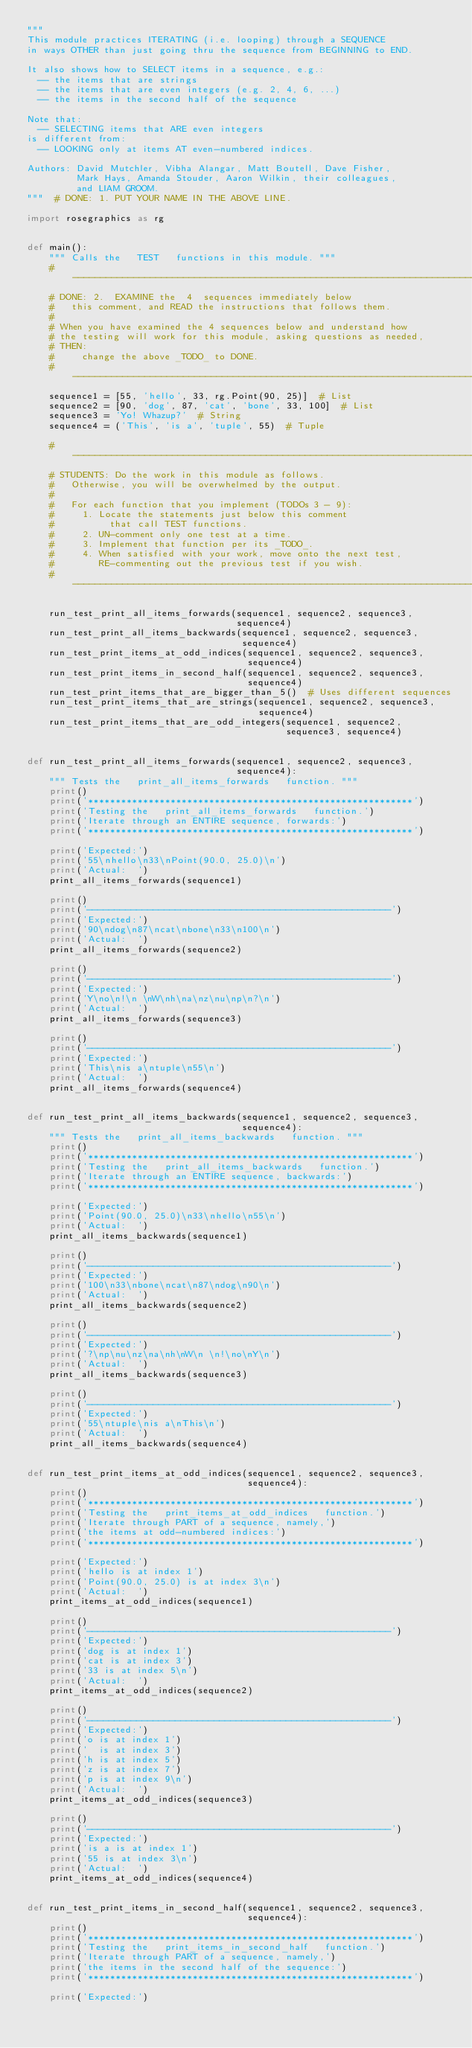<code> <loc_0><loc_0><loc_500><loc_500><_Python_>"""
This module practices ITERATING (i.e. looping) through a SEQUENCE
in ways OTHER than just going thru the sequence from BEGINNING to END.

It also shows how to SELECT items in a sequence, e.g.:
  -- the items that are strings
  -- the items that are even integers (e.g. 2, 4, 6, ...)
  -- the items in the second half of the sequence

Note that:
  -- SELECTING items that ARE even integers
is different from:
  -- LOOKING only at items AT even-numbered indices.

Authors: David Mutchler, Vibha Alangar, Matt Boutell, Dave Fisher,
         Mark Hays, Amanda Stouder, Aaron Wilkin, their colleagues,
         and LIAM GROOM.
"""  # DONE: 1. PUT YOUR NAME IN THE ABOVE LINE.

import rosegraphics as rg


def main():
    """ Calls the   TEST   functions in this module. """
    # -------------------------------------------------------------------------
    # DONE: 2.  EXAMINE the  4  sequences immediately below
    #   this comment, and READ the instructions that follows them.
    #
    # When you have examined the 4 sequences below and understand how
    # the testing will work for this module, asking questions as needed,
    # THEN:
    #     change the above _TODO_ to DONE.
    # -------------------------------------------------------------------------
    sequence1 = [55, 'hello', 33, rg.Point(90, 25)]  # List
    sequence2 = [90, 'dog', 87, 'cat', 'bone', 33, 100]  # List
    sequence3 = 'Yo! Whazup?'  # String
    sequence4 = ('This', 'is a', 'tuple', 55)  # Tuple

    # -------------------------------------------------------------------------
    # STUDENTS: Do the work in this module as follows.
    #   Otherwise, you will be overwhelmed by the output.
    #
    #   For each function that you implement (TODOs 3 - 9):
    #     1. Locate the statements just below this comment
    #          that call TEST functions.
    #     2. UN-comment only one test at a time.
    #     3. Implement that function per its _TODO_.
    #     4. When satisfied with your work, move onto the next test,
    #        RE-commenting out the previous test if you wish.
    # -------------------------------------------------------------------------

    run_test_print_all_items_forwards(sequence1, sequence2, sequence3,
                                      sequence4)
    run_test_print_all_items_backwards(sequence1, sequence2, sequence3,
                                       sequence4)
    run_test_print_items_at_odd_indices(sequence1, sequence2, sequence3,
                                        sequence4)
    run_test_print_items_in_second_half(sequence1, sequence2, sequence3,
                                        sequence4)
    run_test_print_items_that_are_bigger_than_5()  # Uses different sequences
    run_test_print_items_that_are_strings(sequence1, sequence2, sequence3,
                                          sequence4)
    run_test_print_items_that_are_odd_integers(sequence1, sequence2,
                                               sequence3, sequence4)


def run_test_print_all_items_forwards(sequence1, sequence2, sequence3,
                                      sequence4):
    """ Tests the   print_all_items_forwards   function. """
    print()
    print('***********************************************************')
    print('Testing the   print_all_items_forwards   function.')
    print('Iterate through an ENTIRE sequence, forwards:')
    print('***********************************************************')

    print('Expected:')
    print('55\nhello\n33\nPoint(90.0, 25.0)\n')
    print('Actual:  ')
    print_all_items_forwards(sequence1)

    print()
    print('-------------------------------------------------------')
    print('Expected:')
    print('90\ndog\n87\ncat\nbone\n33\n100\n')
    print('Actual:  ')
    print_all_items_forwards(sequence2)

    print()
    print('-------------------------------------------------------')
    print('Expected:')
    print('Y\no\n!\n \nW\nh\na\nz\nu\np\n?\n')
    print('Actual:  ')
    print_all_items_forwards(sequence3)

    print()
    print('-------------------------------------------------------')
    print('Expected:')
    print('This\nis a\ntuple\n55\n')
    print('Actual:  ')
    print_all_items_forwards(sequence4)


def run_test_print_all_items_backwards(sequence1, sequence2, sequence3,
                                       sequence4):
    """ Tests the   print_all_items_backwards   function. """
    print()
    print('***********************************************************')
    print('Testing the   print_all_items_backwards   function.')
    print('Iterate through an ENTIRE sequence, backwards:')
    print('***********************************************************')

    print('Expected:')
    print('Point(90.0, 25.0)\n33\nhello\n55\n')
    print('Actual:  ')
    print_all_items_backwards(sequence1)

    print()
    print('-------------------------------------------------------')
    print('Expected:')
    print('100\n33\nbone\ncat\n87\ndog\n90\n')
    print('Actual:  ')
    print_all_items_backwards(sequence2)

    print()
    print('-------------------------------------------------------')
    print('Expected:')
    print('?\np\nu\nz\na\nh\nW\n \n!\no\nY\n')
    print('Actual:  ')
    print_all_items_backwards(sequence3)

    print()
    print('-------------------------------------------------------')
    print('Expected:')
    print('55\ntuple\nis a\nThis\n')
    print('Actual:  ')
    print_all_items_backwards(sequence4)


def run_test_print_items_at_odd_indices(sequence1, sequence2, sequence3,
                                        sequence4):
    print()
    print('***********************************************************')
    print('Testing the   print_items_at_odd_indices   function.')
    print('Iterate through PART of a sequence, namely,')
    print('the items at odd-numbered indices:')
    print('***********************************************************')

    print('Expected:')
    print('hello is at index 1')
    print('Point(90.0, 25.0) is at index 3\n')
    print('Actual:  ')
    print_items_at_odd_indices(sequence1)

    print()
    print('-------------------------------------------------------')
    print('Expected:')
    print('dog is at index 1')
    print('cat is at index 3')
    print('33 is at index 5\n')
    print('Actual:  ')
    print_items_at_odd_indices(sequence2)

    print()
    print('-------------------------------------------------------')
    print('Expected:')
    print('o is at index 1')
    print('  is at index 3')
    print('h is at index 5')
    print('z is at index 7')
    print('p is at index 9\n')
    print('Actual:  ')
    print_items_at_odd_indices(sequence3)

    print()
    print('-------------------------------------------------------')
    print('Expected:')
    print('is a is at index 1')
    print('55 is at index 3\n')
    print('Actual:  ')
    print_items_at_odd_indices(sequence4)


def run_test_print_items_in_second_half(sequence1, sequence2, sequence3,
                                        sequence4):
    print()
    print('***********************************************************')
    print('Testing the   print_items_in_second_half   function.')
    print('Iterate through PART of a sequence, namely,')
    print('the items in the second half of the sequence:')
    print('***********************************************************')

    print('Expected:')</code> 